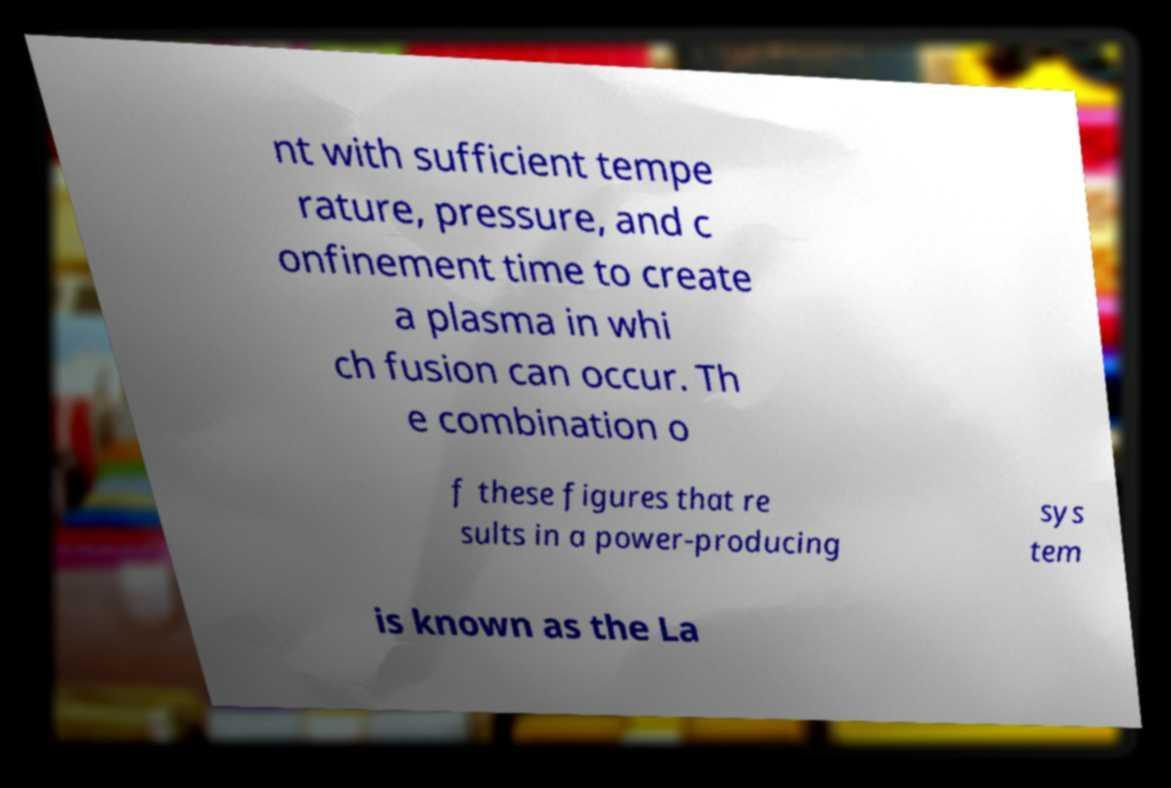Can you read and provide the text displayed in the image?This photo seems to have some interesting text. Can you extract and type it out for me? nt with sufficient tempe rature, pressure, and c onfinement time to create a plasma in whi ch fusion can occur. Th e combination o f these figures that re sults in a power-producing sys tem is known as the La 